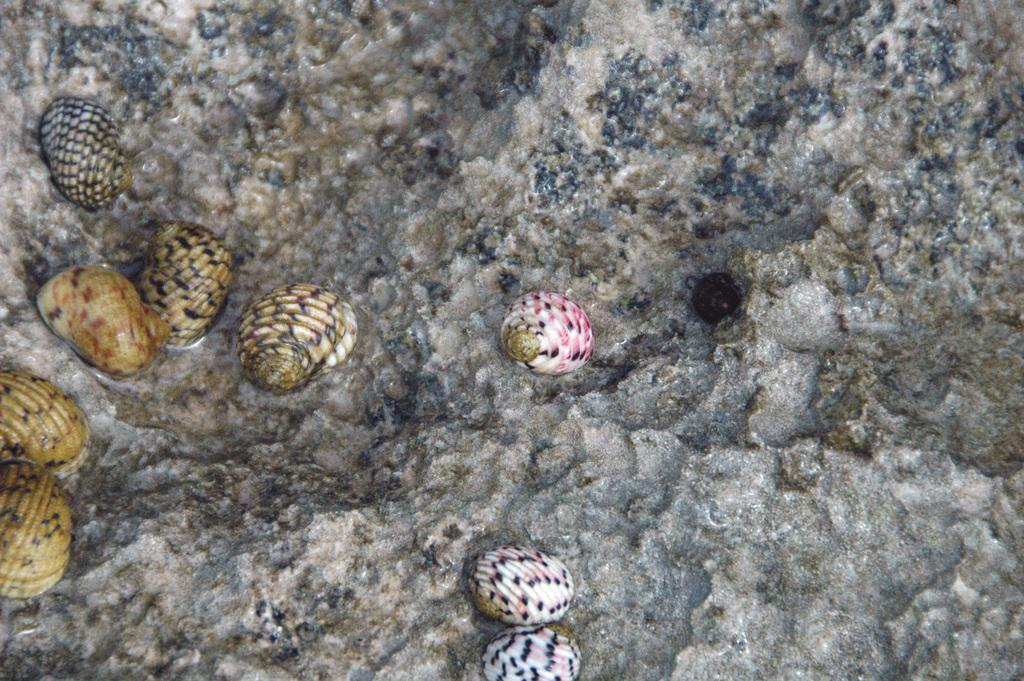What objects are in the foreground of the image? There are seashells in the foreground of the image. Where are the seashells located? The seashells are on a rock. What type of flock can be seen flying over the seashells in the image? There is no flock visible in the image; it only features seashells on a rock. 